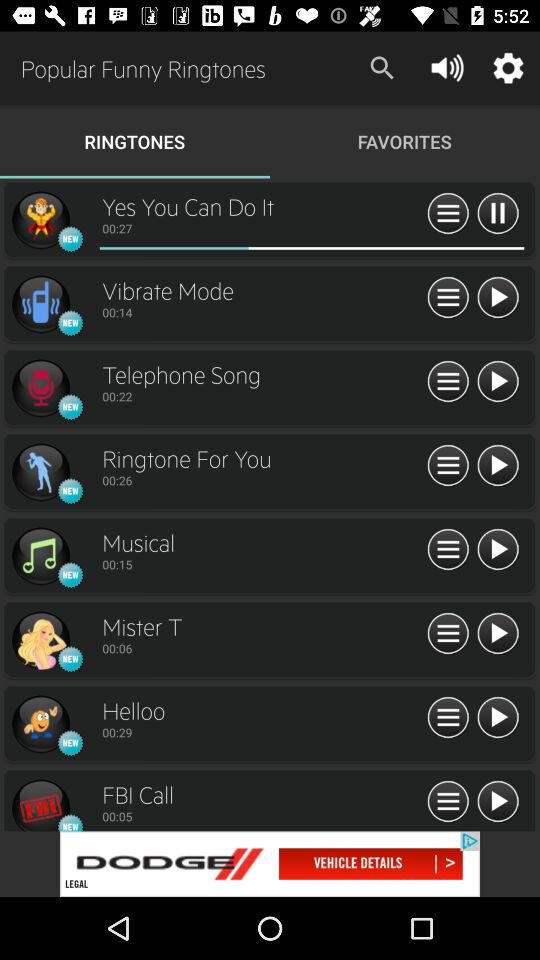What is the selected tab? The selected tab is "RINGTONES". 